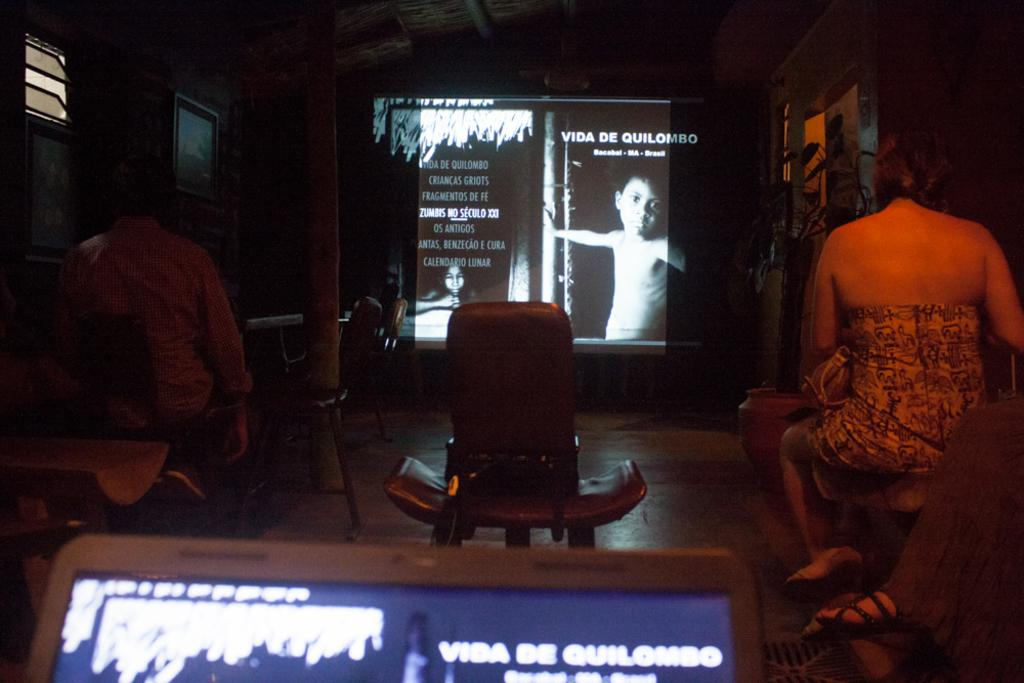What is the lighting condition in the room depicted in the image? The room in the image is dark. What can be seen on the wall in the image? There is a screen on the wall. What is displayed on the screen? A kid is displayed on the screen. How many people are sitting in the room? There are two persons sitting on chairs. What type of device is visible at the bottom of the image? There is a device screen visible at the bottom of the image. What type of teaching is happening in the downtown area in the image? There is no downtown area or teaching activity depicted in the image; it shows a dark room with a screen and two persons sitting on chairs. 